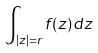Convert formula to latex. <formula><loc_0><loc_0><loc_500><loc_500>\int _ { | z | = r } f ( z ) d z</formula> 